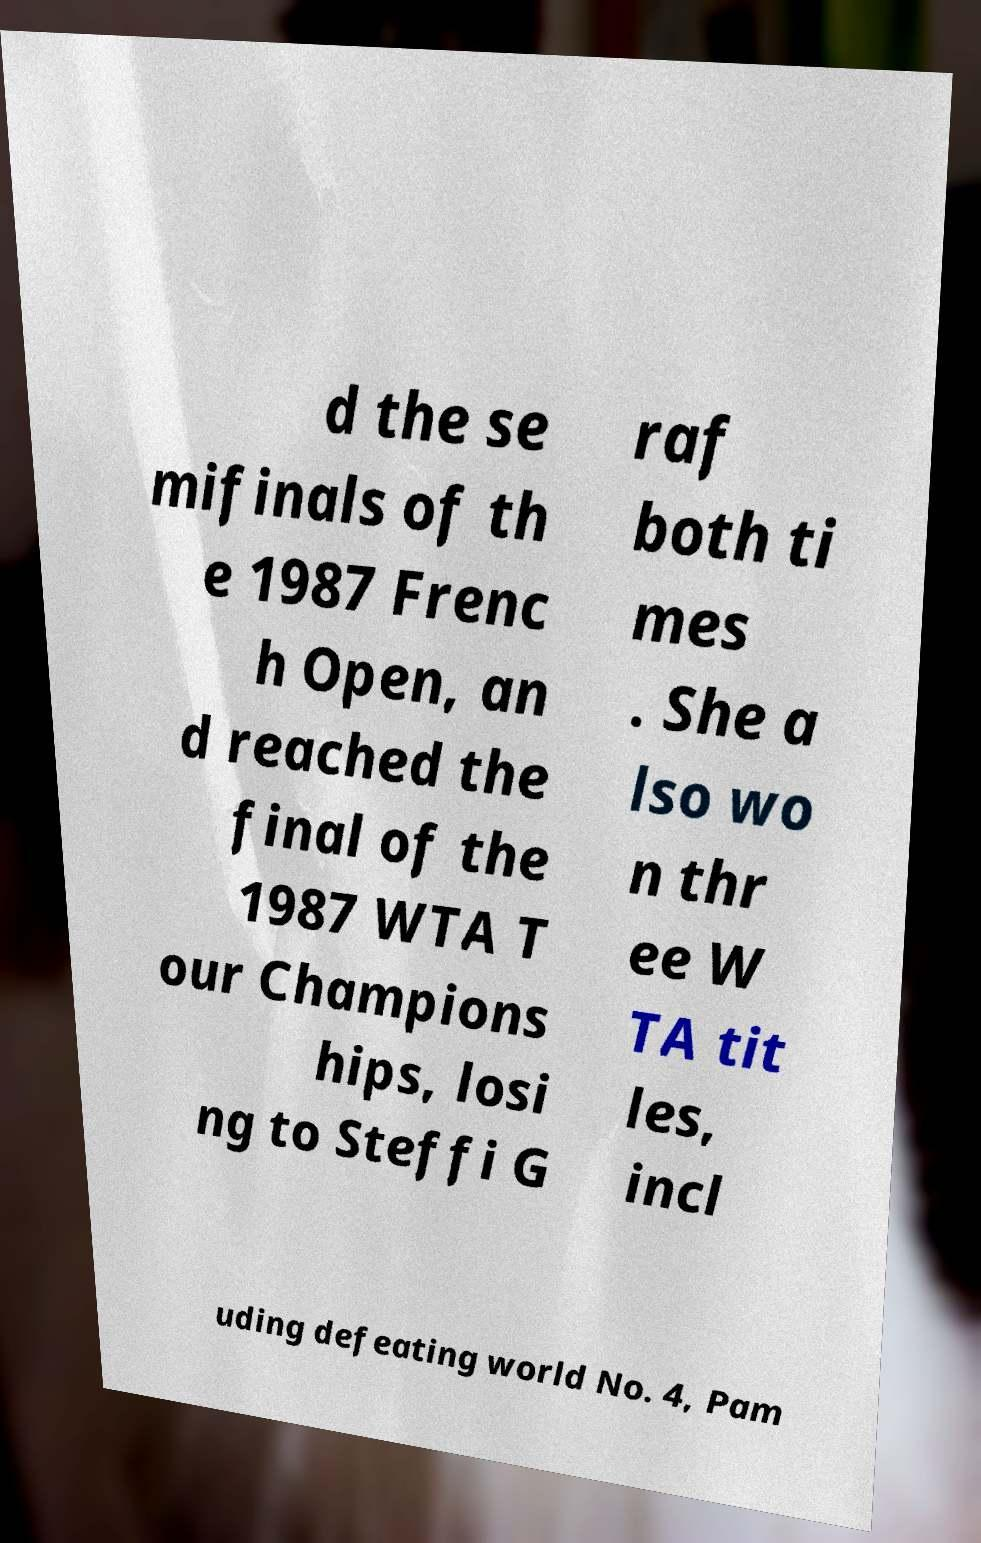Can you accurately transcribe the text from the provided image for me? d the se mifinals of th e 1987 Frenc h Open, an d reached the final of the 1987 WTA T our Champions hips, losi ng to Steffi G raf both ti mes . She a lso wo n thr ee W TA tit les, incl uding defeating world No. 4, Pam 